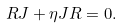<formula> <loc_0><loc_0><loc_500><loc_500>R J + \eta J R = 0 .</formula> 